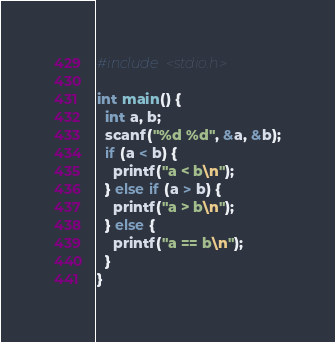Convert code to text. <code><loc_0><loc_0><loc_500><loc_500><_C_>#include <stdio.h>

int main() {
  int a, b;
  scanf("%d %d", &a, &b);
  if (a < b) {
    printf("a < b\n");
  } else if (a > b) {
    printf("a > b\n");
  } else {
    printf("a == b\n");
  }
}

</code> 